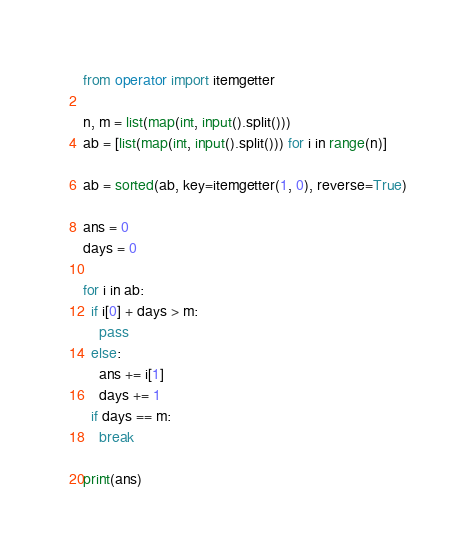Convert code to text. <code><loc_0><loc_0><loc_500><loc_500><_Python_>from operator import itemgetter

n, m = list(map(int, input().split()))
ab = [list(map(int, input().split())) for i in range(n)]

ab = sorted(ab, key=itemgetter(1, 0), reverse=True)

ans = 0
days = 0

for i in ab:
  if i[0] + days > m:
    pass
  else:
    ans += i[1]
    days += 1
  if days == m:
    break

print(ans)
</code> 